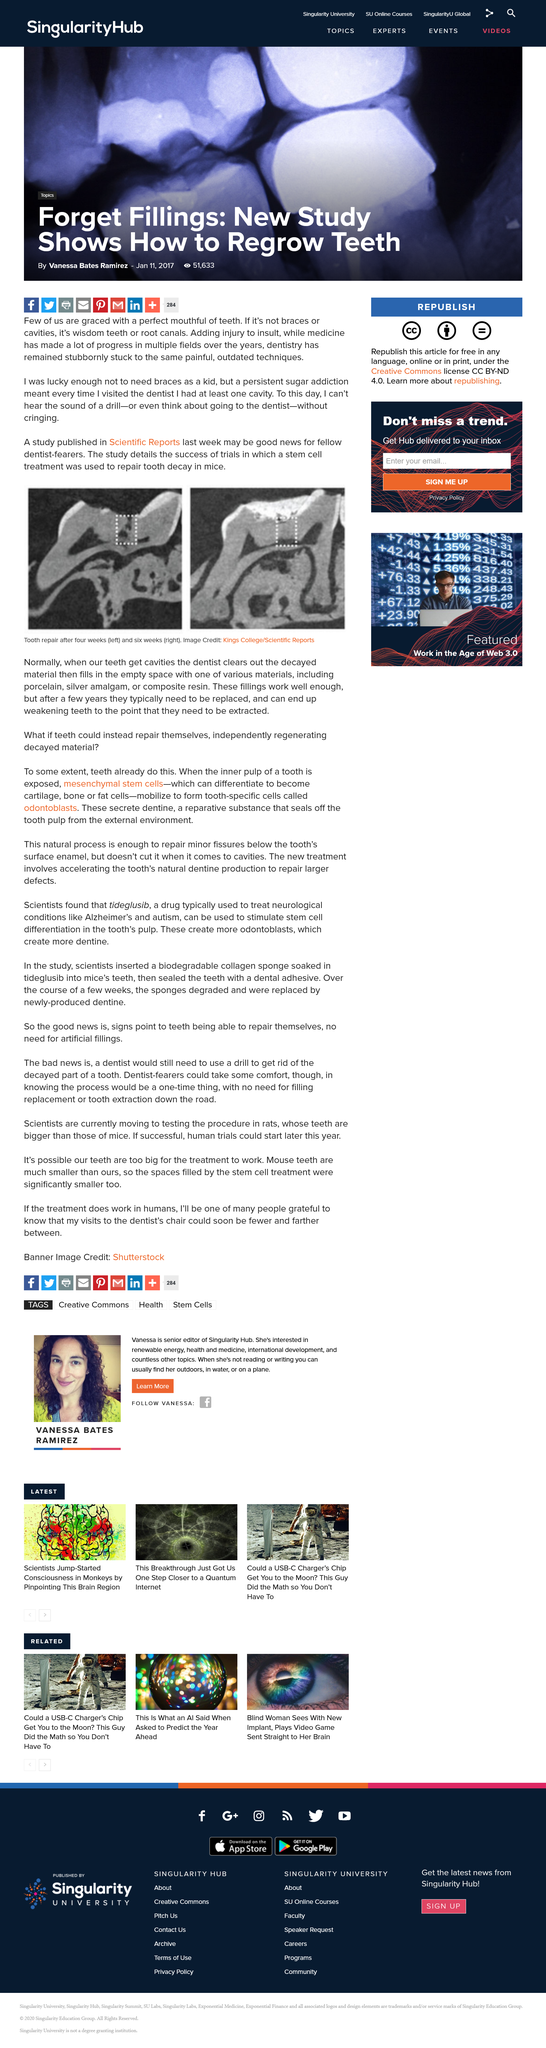Highlight a few significant elements in this photo. The left photo shows tooth repair after four weeks, which is featured in the left photo. A stem cell treatment study was published in Scientific Reports, detailing the effects of the treatment on participants. Yes, mesenchymal stem cells can become cartilage. 